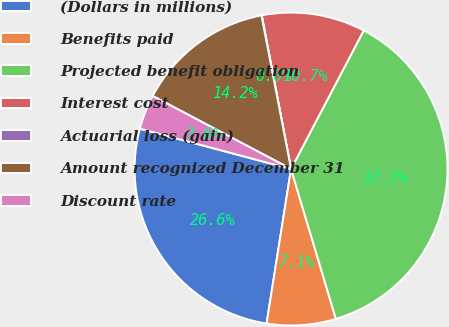Convert chart to OTSL. <chart><loc_0><loc_0><loc_500><loc_500><pie_chart><fcel>(Dollars in millions)<fcel>Benefits paid<fcel>Projected benefit obligation<fcel>Interest cost<fcel>Actuarial loss (gain)<fcel>Amount recognized December 31<fcel>Discount rate<nl><fcel>26.65%<fcel>7.13%<fcel>37.68%<fcel>10.69%<fcel>0.03%<fcel>14.24%<fcel>3.58%<nl></chart> 